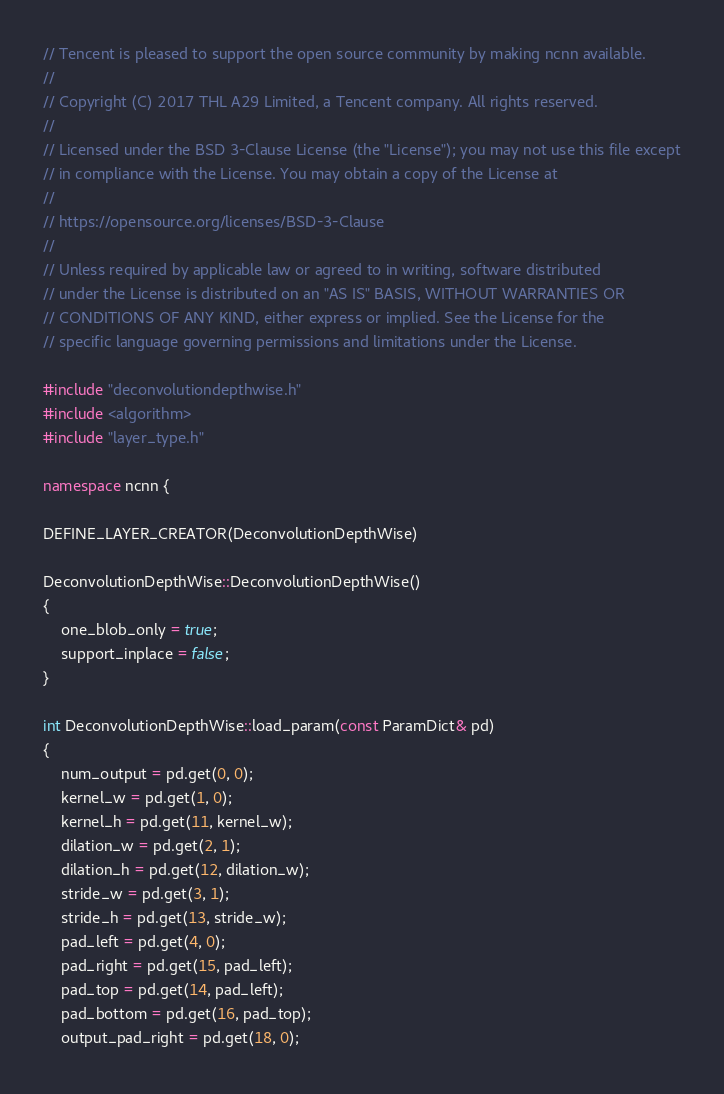Convert code to text. <code><loc_0><loc_0><loc_500><loc_500><_C++_>// Tencent is pleased to support the open source community by making ncnn available.
//
// Copyright (C) 2017 THL A29 Limited, a Tencent company. All rights reserved.
//
// Licensed under the BSD 3-Clause License (the "License"); you may not use this file except
// in compliance with the License. You may obtain a copy of the License at
//
// https://opensource.org/licenses/BSD-3-Clause
//
// Unless required by applicable law or agreed to in writing, software distributed
// under the License is distributed on an "AS IS" BASIS, WITHOUT WARRANTIES OR
// CONDITIONS OF ANY KIND, either express or implied. See the License for the
// specific language governing permissions and limitations under the License.

#include "deconvolutiondepthwise.h"
#include <algorithm>
#include "layer_type.h"

namespace ncnn {

DEFINE_LAYER_CREATOR(DeconvolutionDepthWise)

DeconvolutionDepthWise::DeconvolutionDepthWise()
{
    one_blob_only = true;
    support_inplace = false;
}

int DeconvolutionDepthWise::load_param(const ParamDict& pd)
{
    num_output = pd.get(0, 0);
    kernel_w = pd.get(1, 0);
    kernel_h = pd.get(11, kernel_w);
    dilation_w = pd.get(2, 1);
    dilation_h = pd.get(12, dilation_w);
    stride_w = pd.get(3, 1);
    stride_h = pd.get(13, stride_w);
    pad_left = pd.get(4, 0);
    pad_right = pd.get(15, pad_left);
    pad_top = pd.get(14, pad_left);
    pad_bottom = pd.get(16, pad_top);
    output_pad_right = pd.get(18, 0);</code> 